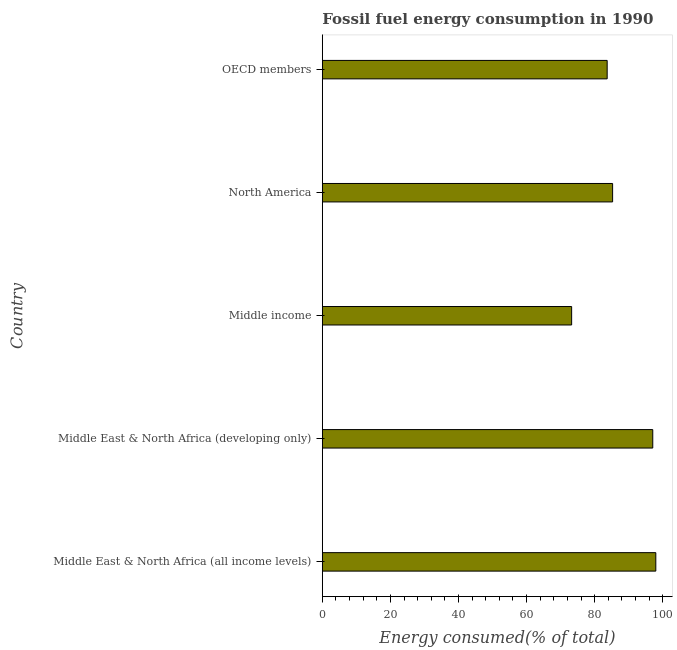Does the graph contain any zero values?
Your answer should be compact. No. Does the graph contain grids?
Give a very brief answer. No. What is the title of the graph?
Offer a very short reply. Fossil fuel energy consumption in 1990. What is the label or title of the X-axis?
Provide a succinct answer. Energy consumed(% of total). What is the label or title of the Y-axis?
Ensure brevity in your answer.  Country. What is the fossil fuel energy consumption in Middle East & North Africa (developing only)?
Provide a succinct answer. 97.07. Across all countries, what is the maximum fossil fuel energy consumption?
Your answer should be very brief. 97.97. Across all countries, what is the minimum fossil fuel energy consumption?
Keep it short and to the point. 73.24. In which country was the fossil fuel energy consumption maximum?
Offer a terse response. Middle East & North Africa (all income levels). What is the sum of the fossil fuel energy consumption?
Your response must be concise. 437.22. What is the difference between the fossil fuel energy consumption in Middle income and OECD members?
Your response must be concise. -10.44. What is the average fossil fuel energy consumption per country?
Your answer should be very brief. 87.44. What is the median fossil fuel energy consumption?
Provide a succinct answer. 85.27. What is the ratio of the fossil fuel energy consumption in Middle income to that in OECD members?
Give a very brief answer. 0.88. Is the fossil fuel energy consumption in Middle East & North Africa (all income levels) less than that in OECD members?
Your answer should be very brief. No. What is the difference between the highest and the second highest fossil fuel energy consumption?
Offer a terse response. 0.9. What is the difference between the highest and the lowest fossil fuel energy consumption?
Your answer should be very brief. 24.73. In how many countries, is the fossil fuel energy consumption greater than the average fossil fuel energy consumption taken over all countries?
Your answer should be compact. 2. How many bars are there?
Offer a terse response. 5. Are all the bars in the graph horizontal?
Your response must be concise. Yes. How many countries are there in the graph?
Make the answer very short. 5. What is the difference between two consecutive major ticks on the X-axis?
Give a very brief answer. 20. Are the values on the major ticks of X-axis written in scientific E-notation?
Your answer should be compact. No. What is the Energy consumed(% of total) of Middle East & North Africa (all income levels)?
Offer a terse response. 97.97. What is the Energy consumed(% of total) of Middle East & North Africa (developing only)?
Your answer should be compact. 97.07. What is the Energy consumed(% of total) of Middle income?
Provide a succinct answer. 73.24. What is the Energy consumed(% of total) in North America?
Offer a terse response. 85.27. What is the Energy consumed(% of total) of OECD members?
Give a very brief answer. 83.68. What is the difference between the Energy consumed(% of total) in Middle East & North Africa (all income levels) and Middle East & North Africa (developing only)?
Keep it short and to the point. 0.9. What is the difference between the Energy consumed(% of total) in Middle East & North Africa (all income levels) and Middle income?
Your response must be concise. 24.73. What is the difference between the Energy consumed(% of total) in Middle East & North Africa (all income levels) and North America?
Provide a short and direct response. 12.69. What is the difference between the Energy consumed(% of total) in Middle East & North Africa (all income levels) and OECD members?
Provide a succinct answer. 14.29. What is the difference between the Energy consumed(% of total) in Middle East & North Africa (developing only) and Middle income?
Make the answer very short. 23.83. What is the difference between the Energy consumed(% of total) in Middle East & North Africa (developing only) and North America?
Keep it short and to the point. 11.8. What is the difference between the Energy consumed(% of total) in Middle East & North Africa (developing only) and OECD members?
Make the answer very short. 13.39. What is the difference between the Energy consumed(% of total) in Middle income and North America?
Give a very brief answer. -12.03. What is the difference between the Energy consumed(% of total) in Middle income and OECD members?
Provide a short and direct response. -10.44. What is the difference between the Energy consumed(% of total) in North America and OECD members?
Your answer should be very brief. 1.59. What is the ratio of the Energy consumed(% of total) in Middle East & North Africa (all income levels) to that in Middle income?
Provide a short and direct response. 1.34. What is the ratio of the Energy consumed(% of total) in Middle East & North Africa (all income levels) to that in North America?
Keep it short and to the point. 1.15. What is the ratio of the Energy consumed(% of total) in Middle East & North Africa (all income levels) to that in OECD members?
Give a very brief answer. 1.17. What is the ratio of the Energy consumed(% of total) in Middle East & North Africa (developing only) to that in Middle income?
Your answer should be compact. 1.32. What is the ratio of the Energy consumed(% of total) in Middle East & North Africa (developing only) to that in North America?
Make the answer very short. 1.14. What is the ratio of the Energy consumed(% of total) in Middle East & North Africa (developing only) to that in OECD members?
Keep it short and to the point. 1.16. What is the ratio of the Energy consumed(% of total) in Middle income to that in North America?
Give a very brief answer. 0.86. What is the ratio of the Energy consumed(% of total) in North America to that in OECD members?
Ensure brevity in your answer.  1.02. 